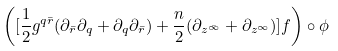Convert formula to latex. <formula><loc_0><loc_0><loc_500><loc_500>\left ( [ \frac { 1 } { 2 } g ^ { q \bar { r } } ( \partial _ { \bar { r } } \partial _ { q } + \partial _ { q } \partial _ { \bar { r } } ) + \frac { n } { 2 } ( \partial _ { z ^ { \bar { \infty } } } + \partial _ { z ^ { \infty } } ) ] f \right ) \circ \phi</formula> 